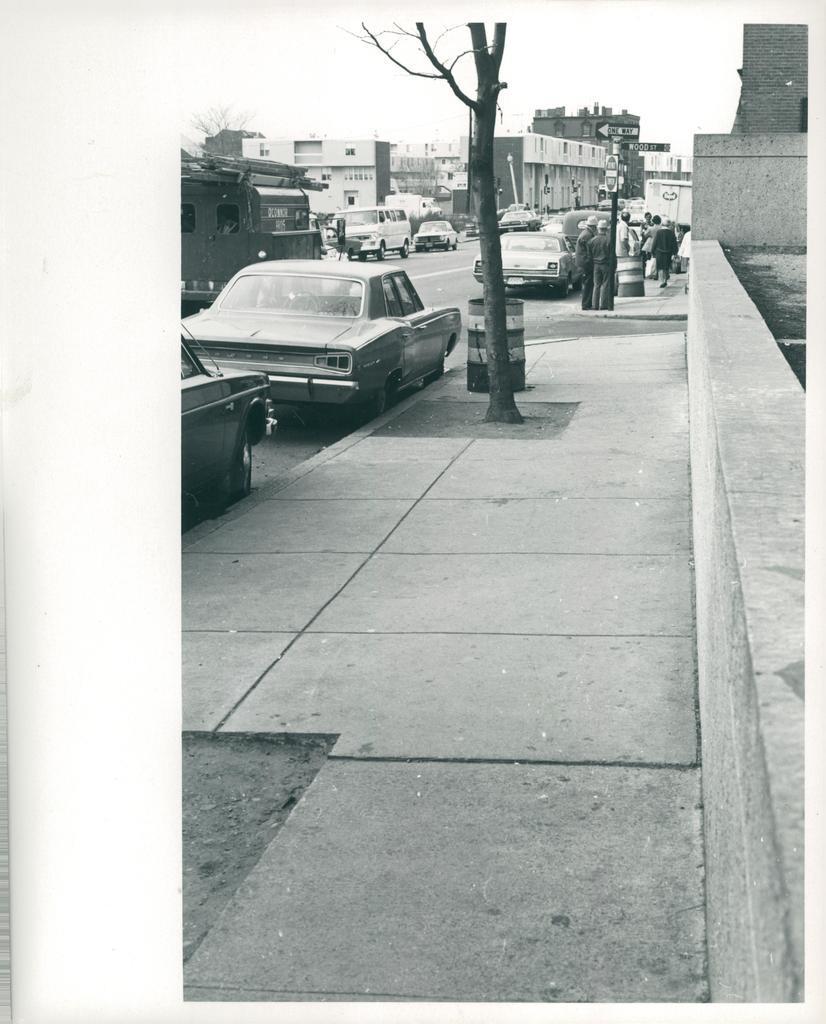Please provide a concise description of this image. In this image we can see black and white picture of some vehicles parked on the road, a container, tree, a group of people standing on the ground and buildings with windows. At the top of the image we can see the sky. 